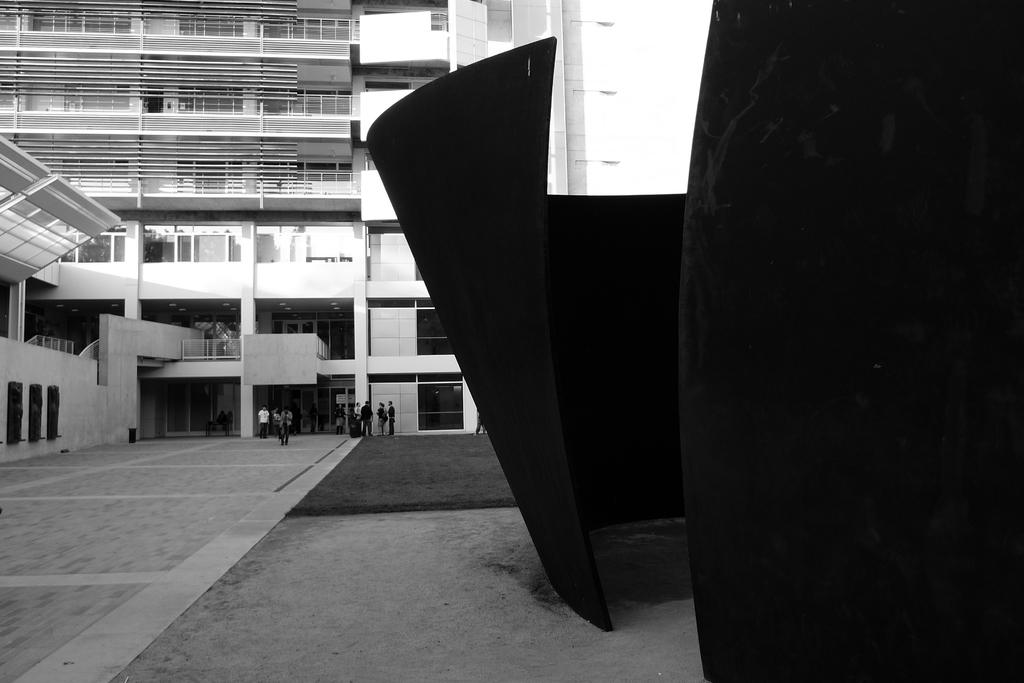What is the main structure in the center of the image? There is a building in the center of the image. What can be seen on the right side of the image? There is a wall on the right side of the image. What is happening at the bottom of the image? People are standing at the bottom of the image. What is present at the bottom of the image for people to stand on? There is a mat at the bottom of the image. Where is the desk located in the image? There is no desk present in the image. What type of reward can be seen being given to the people in the image? There is no reward being given to the people in the image. 